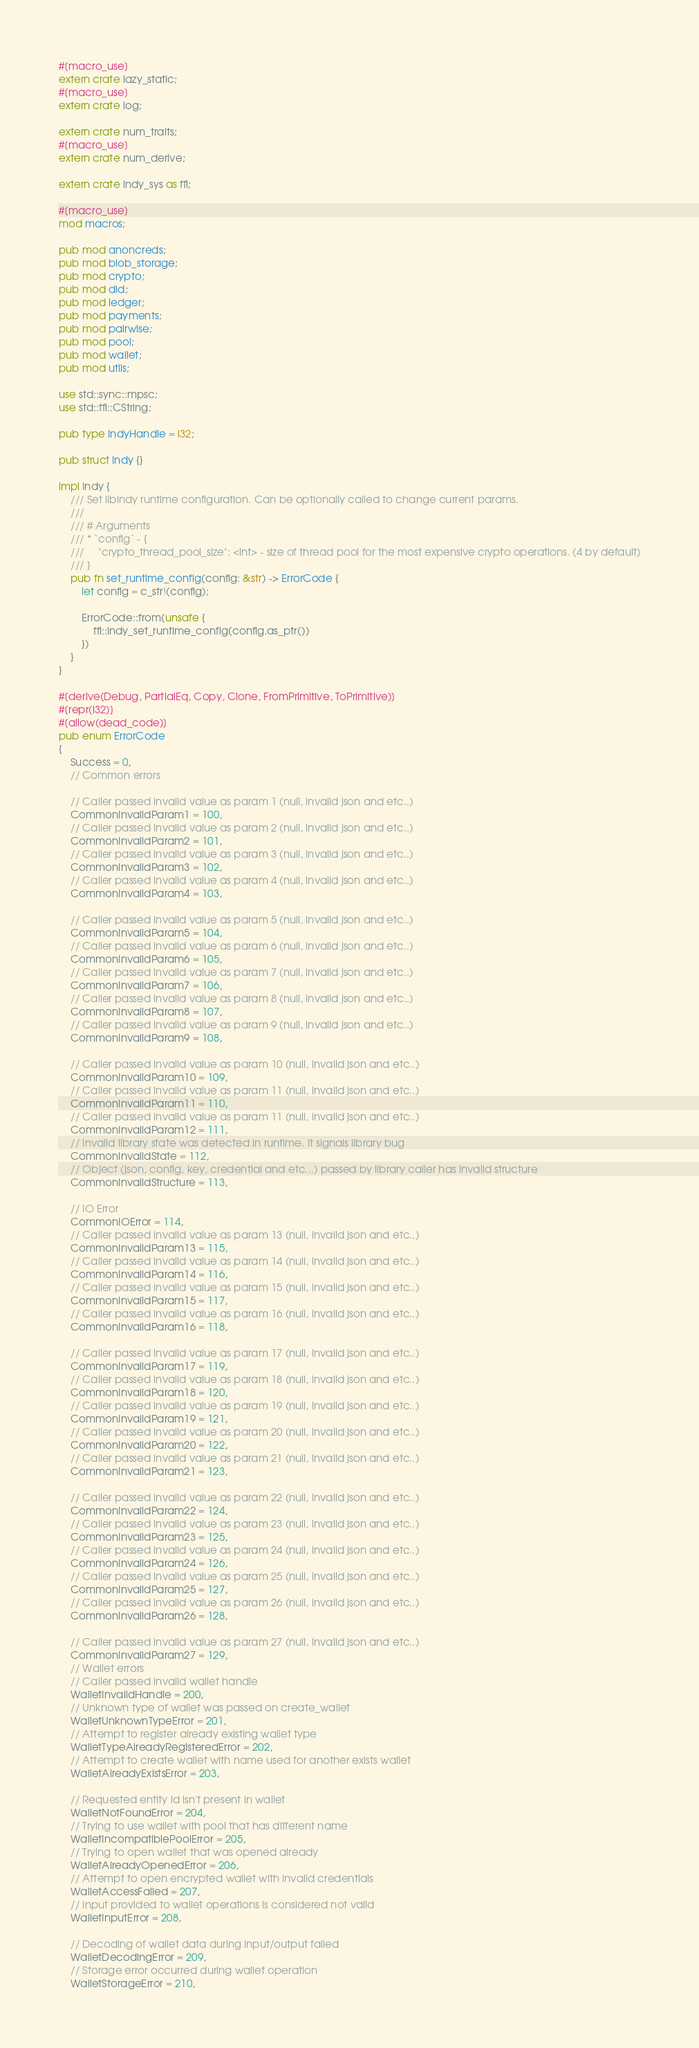Convert code to text. <code><loc_0><loc_0><loc_500><loc_500><_Rust_>#[macro_use]
extern crate lazy_static;
#[macro_use]
extern crate log;

extern crate num_traits;
#[macro_use]
extern crate num_derive;

extern crate indy_sys as ffi;

#[macro_use]
mod macros;

pub mod anoncreds;
pub mod blob_storage;
pub mod crypto;
pub mod did;
pub mod ledger;
pub mod payments;
pub mod pairwise;
pub mod pool;
pub mod wallet;
pub mod utils;

use std::sync::mpsc;
use std::ffi::CString;

pub type IndyHandle = i32;

pub struct Indy {}

impl Indy {
    /// Set libindy runtime configuration. Can be optionally called to change current params.
    ///
    /// # Arguments
    /// * `config` - {
    ///     "crypto_thread_pool_size": <int> - size of thread pool for the most expensive crypto operations. (4 by default)
    /// }
    pub fn set_runtime_config(config: &str) -> ErrorCode {
        let config = c_str!(config);

        ErrorCode::from(unsafe {
            ffi::indy_set_runtime_config(config.as_ptr())
        })
    }
}

#[derive(Debug, PartialEq, Copy, Clone, FromPrimitive, ToPrimitive)]
#[repr(i32)]
#[allow(dead_code)]
pub enum ErrorCode
{
    Success = 0,
    // Common errors

    // Caller passed invalid value as param 1 (null, invalid json and etc..)
    CommonInvalidParam1 = 100,
    // Caller passed invalid value as param 2 (null, invalid json and etc..)
    CommonInvalidParam2 = 101,
    // Caller passed invalid value as param 3 (null, invalid json and etc..)
    CommonInvalidParam3 = 102,
    // Caller passed invalid value as param 4 (null, invalid json and etc..)
    CommonInvalidParam4 = 103,

    // Caller passed invalid value as param 5 (null, invalid json and etc..)
    CommonInvalidParam5 = 104,
    // Caller passed invalid value as param 6 (null, invalid json and etc..)
    CommonInvalidParam6 = 105,
    // Caller passed invalid value as param 7 (null, invalid json and etc..)
    CommonInvalidParam7 = 106,
    // Caller passed invalid value as param 8 (null, invalid json and etc..)
    CommonInvalidParam8 = 107,
    // Caller passed invalid value as param 9 (null, invalid json and etc..)
    CommonInvalidParam9 = 108,

    // Caller passed invalid value as param 10 (null, invalid json and etc..)
    CommonInvalidParam10 = 109,
    // Caller passed invalid value as param 11 (null, invalid json and etc..)
    CommonInvalidParam11 = 110,
    // Caller passed invalid value as param 11 (null, invalid json and etc..)
    CommonInvalidParam12 = 111,
    // Invalid library state was detected in runtime. It signals library bug
    CommonInvalidState = 112,
    // Object (json, config, key, credential and etc...) passed by library caller has invalid structure
    CommonInvalidStructure = 113,

    // IO Error
    CommonIOError = 114,
    // Caller passed invalid value as param 13 (null, invalid json and etc..)
    CommonInvalidParam13 = 115,
    // Caller passed invalid value as param 14 (null, invalid json and etc..)
    CommonInvalidParam14 = 116,
    // Caller passed invalid value as param 15 (null, invalid json and etc..)
    CommonInvalidParam15 = 117,
    // Caller passed invalid value as param 16 (null, invalid json and etc..)
    CommonInvalidParam16 = 118,

    // Caller passed invalid value as param 17 (null, invalid json and etc..)
    CommonInvalidParam17 = 119,
    // Caller passed invalid value as param 18 (null, invalid json and etc..)
    CommonInvalidParam18 = 120,
    // Caller passed invalid value as param 19 (null, invalid json and etc..)
    CommonInvalidParam19 = 121,
    // Caller passed invalid value as param 20 (null, invalid json and etc..)
    CommonInvalidParam20 = 122,
    // Caller passed invalid value as param 21 (null, invalid json and etc..)
    CommonInvalidParam21 = 123,

    // Caller passed invalid value as param 22 (null, invalid json and etc..)
    CommonInvalidParam22 = 124,
    // Caller passed invalid value as param 23 (null, invalid json and etc..)
    CommonInvalidParam23 = 125,
    // Caller passed invalid value as param 24 (null, invalid json and etc..)
    CommonInvalidParam24 = 126,
    // Caller passed invalid value as param 25 (null, invalid json and etc..)
    CommonInvalidParam25 = 127,
    // Caller passed invalid value as param 26 (null, invalid json and etc..)
    CommonInvalidParam26 = 128,

    // Caller passed invalid value as param 27 (null, invalid json and etc..)
    CommonInvalidParam27 = 129,
    // Wallet errors
    // Caller passed invalid wallet handle
    WalletInvalidHandle = 200,
    // Unknown type of wallet was passed on create_wallet
    WalletUnknownTypeError = 201,
    // Attempt to register already existing wallet type
    WalletTypeAlreadyRegisteredError = 202,
    // Attempt to create wallet with name used for another exists wallet
    WalletAlreadyExistsError = 203,

    // Requested entity id isn't present in wallet
    WalletNotFoundError = 204,
    // Trying to use wallet with pool that has different name
    WalletIncompatiblePoolError = 205,
    // Trying to open wallet that was opened already
    WalletAlreadyOpenedError = 206,
    // Attempt to open encrypted wallet with invalid credentials
    WalletAccessFailed = 207,
    // Input provided to wallet operations is considered not valid
    WalletInputError = 208,

    // Decoding of wallet data during input/output failed
    WalletDecodingError = 209,
    // Storage error occurred during wallet operation
    WalletStorageError = 210,</code> 